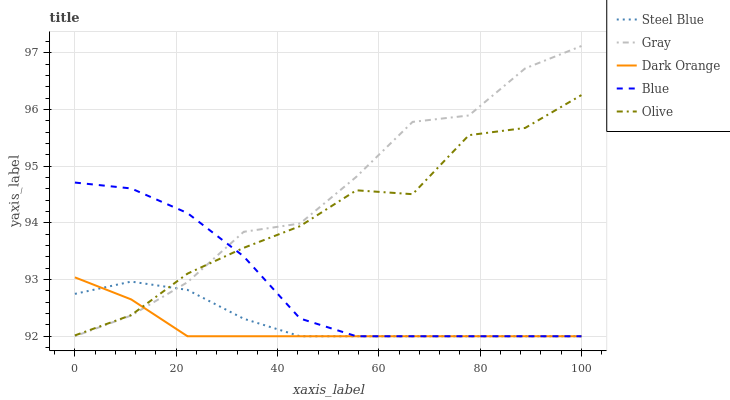Does Dark Orange have the minimum area under the curve?
Answer yes or no. Yes. Does Gray have the maximum area under the curve?
Answer yes or no. Yes. Does Olive have the minimum area under the curve?
Answer yes or no. No. Does Olive have the maximum area under the curve?
Answer yes or no. No. Is Dark Orange the smoothest?
Answer yes or no. Yes. Is Olive the roughest?
Answer yes or no. Yes. Is Gray the smoothest?
Answer yes or no. No. Is Gray the roughest?
Answer yes or no. No. Does Blue have the lowest value?
Answer yes or no. Yes. Does Olive have the lowest value?
Answer yes or no. No. Does Gray have the highest value?
Answer yes or no. Yes. Does Olive have the highest value?
Answer yes or no. No. Does Steel Blue intersect Blue?
Answer yes or no. Yes. Is Steel Blue less than Blue?
Answer yes or no. No. Is Steel Blue greater than Blue?
Answer yes or no. No. 